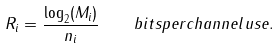Convert formula to latex. <formula><loc_0><loc_0><loc_500><loc_500>R _ { i } = \frac { \log _ { 2 } ( M _ { i } ) } { n _ { i } } \quad b i t s p e r c h a n n e l u s e .</formula> 